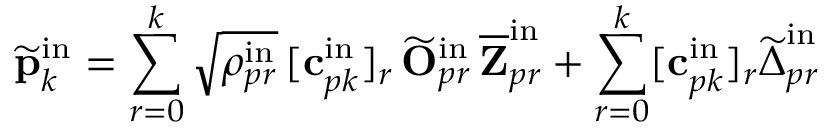<formula> <loc_0><loc_0><loc_500><loc_500>\widetilde { p } _ { k } ^ { i n } = \sum _ { r = 0 } ^ { k } \sqrt { \rho _ { p r } ^ { i n } } \, [ c _ { p k } ^ { i n } ] _ { r } \, \widetilde { O } _ { p r } ^ { i n } \, \overline { Z } _ { p r } ^ { i n } + \sum _ { r = 0 } ^ { k } [ c _ { p k } ^ { i n } ] _ { r } \widetilde { \Delta } _ { p r } ^ { i n }</formula> 